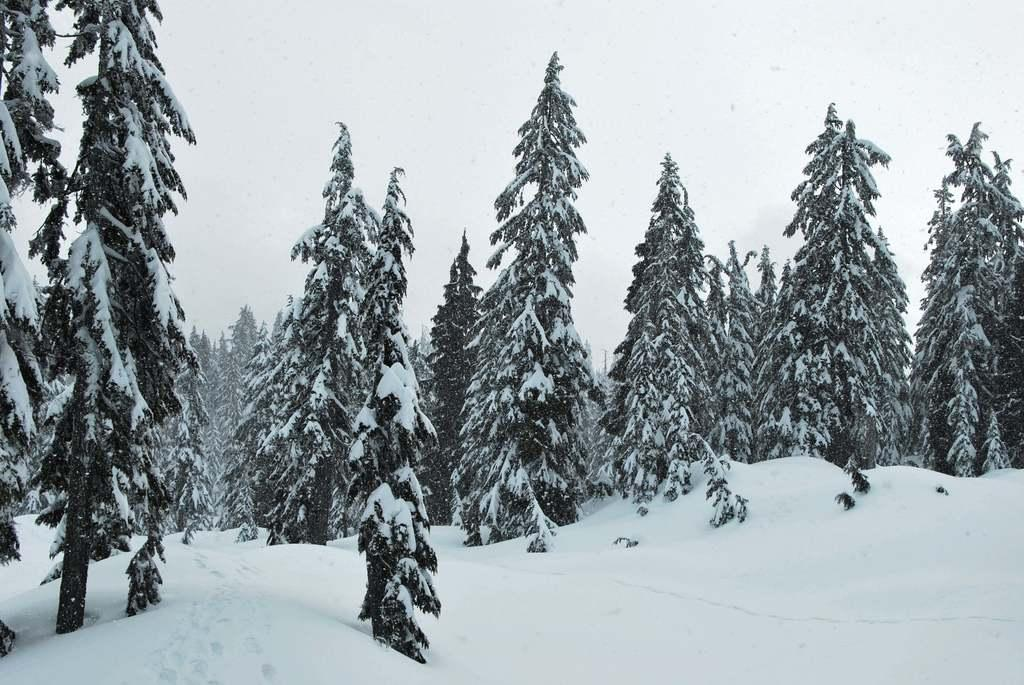What type of vegetation can be seen in the image? There are trees in the image. What is the weather like in the image? There is snow visible in the image, indicating a cold and likely snowy environment. What part of the natural environment is visible in the image? The sky is visible in the image. What type of behavior does the mom exhibit in the image? There is no mention of a mom or any behavior in the image; it only features trees, snow, and the sky. 